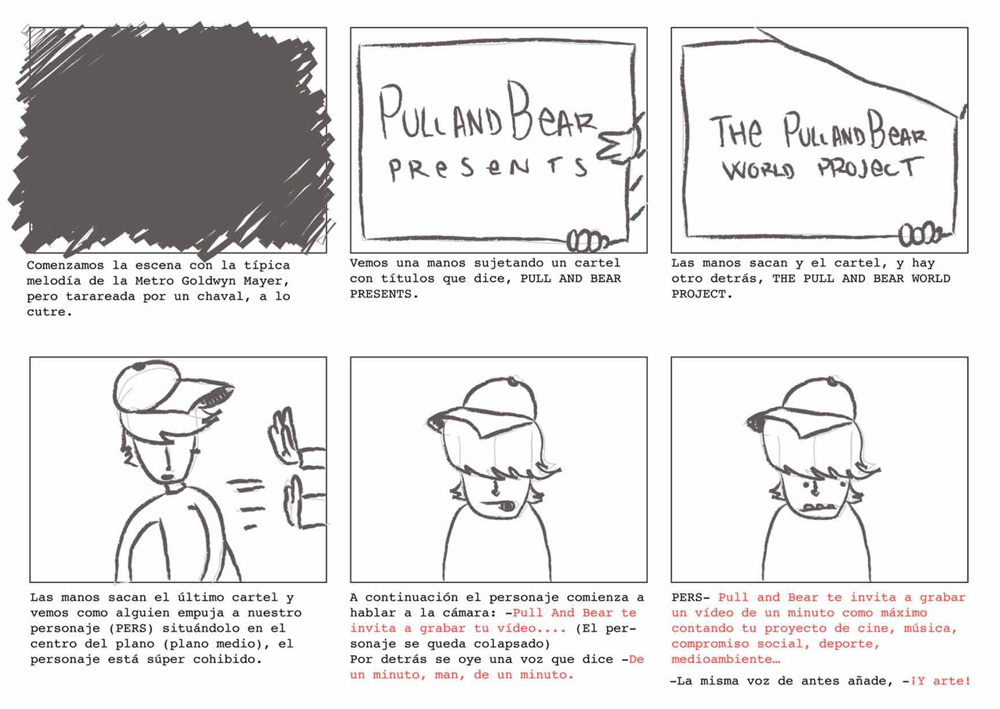What does the text on the poster reveal about the nature of the project? The poster titles 'The Pull and Bear World Project' suggest that the project is likely global in scope and perhaps aims to involve a diverse, international audience. This ambitious project may focus on fields like cinema, music, sports, and environmental issues, intent on making a social or cultural impact. 